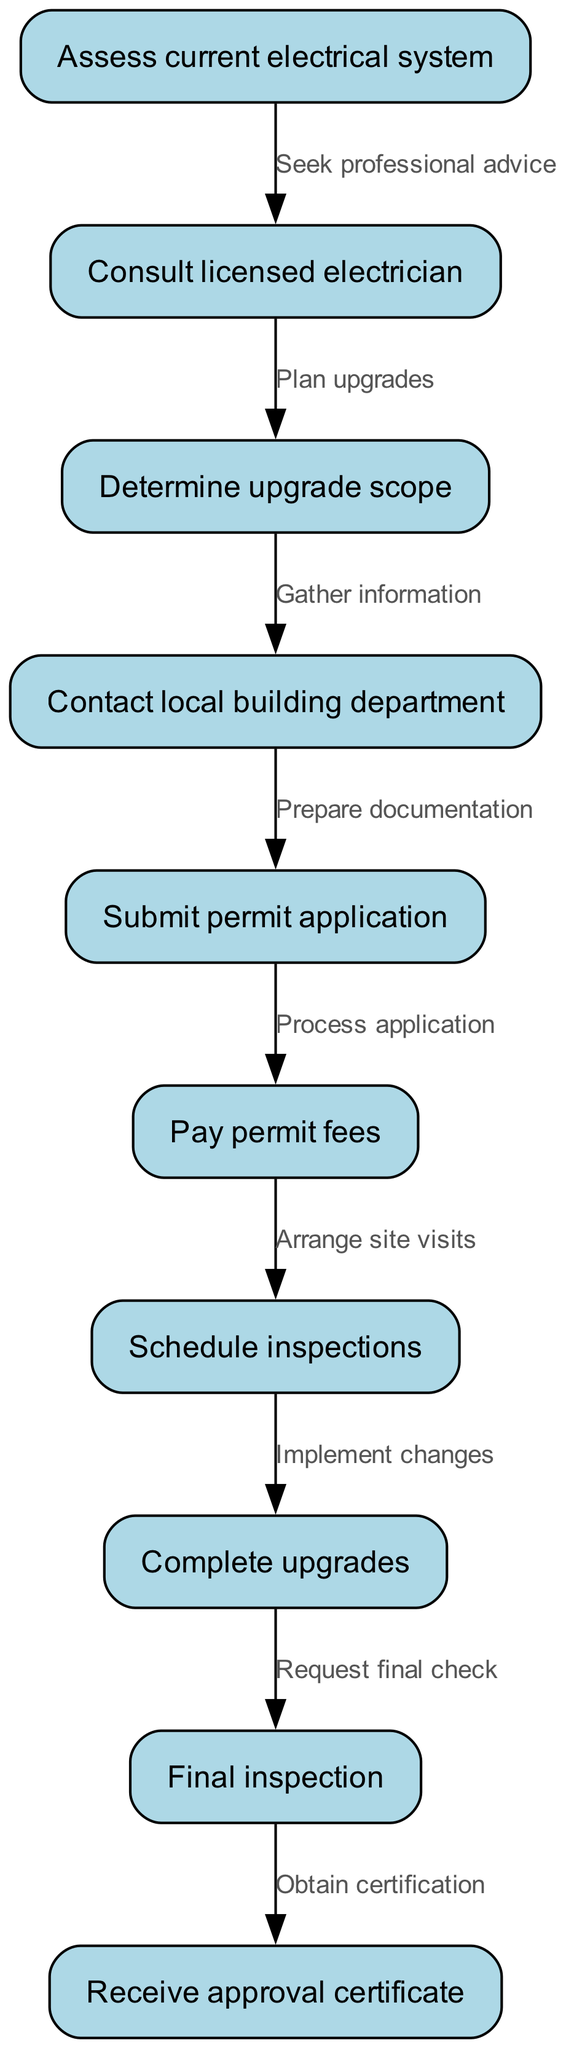What is the first step in the process? The diagram indicates that the process begins with "Assess current electrical system," which is the first node listed.
Answer: Assess current electrical system How many nodes are in the diagram? The diagram contains a total of 10 nodes, as indicated by the nodes section of the provided data.
Answer: 10 What comes after "Schedule inspections"? The diagram shows that after "Schedule inspections," the next step is "Complete upgrades," which is connected by an edge.
Answer: Complete upgrades What is the last step in the process? According to the diagram, the final step is "Receive approval certificate," which is represented as the last node.
Answer: Receive approval certificate What action follows "Submit permit application"? After "Submit permit application," the subsequent action is "Pay permit fees," indicating a direct flow from one step to the next.
Answer: Pay permit fees How many edges are in the diagram? The edges represent the connections between nodes, and the diagram has 9 edges connecting the 10 nodes.
Answer: 9 What is the relationship between "Consult licensed electrician" and "Determine upgrade scope"? "Consult licensed electrician" leads to "Determine upgrade scope," as shown by the directed edge indicating a flow between these two nodes.
Answer: Plan upgrades What must be done after "Contact local building department"? Following "Contact local building department," the next action required is to "Submit permit application," demonstrating a sequential step in the process.
Answer: Submit permit application What type of diagram is this? The diagram is a Flow Chart, which illustrates the step-by-step process involved in obtaining permits and approvals for electrical system upgrades.
Answer: Flow Chart 